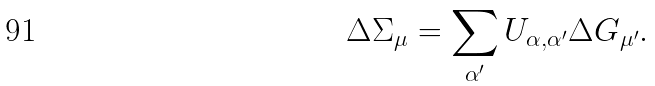<formula> <loc_0><loc_0><loc_500><loc_500>\Delta \Sigma _ { \mu } = \sum _ { \alpha ^ { \prime } } U _ { \alpha , \alpha ^ { \prime } } \Delta G _ { \mu ^ { \prime } } .</formula> 